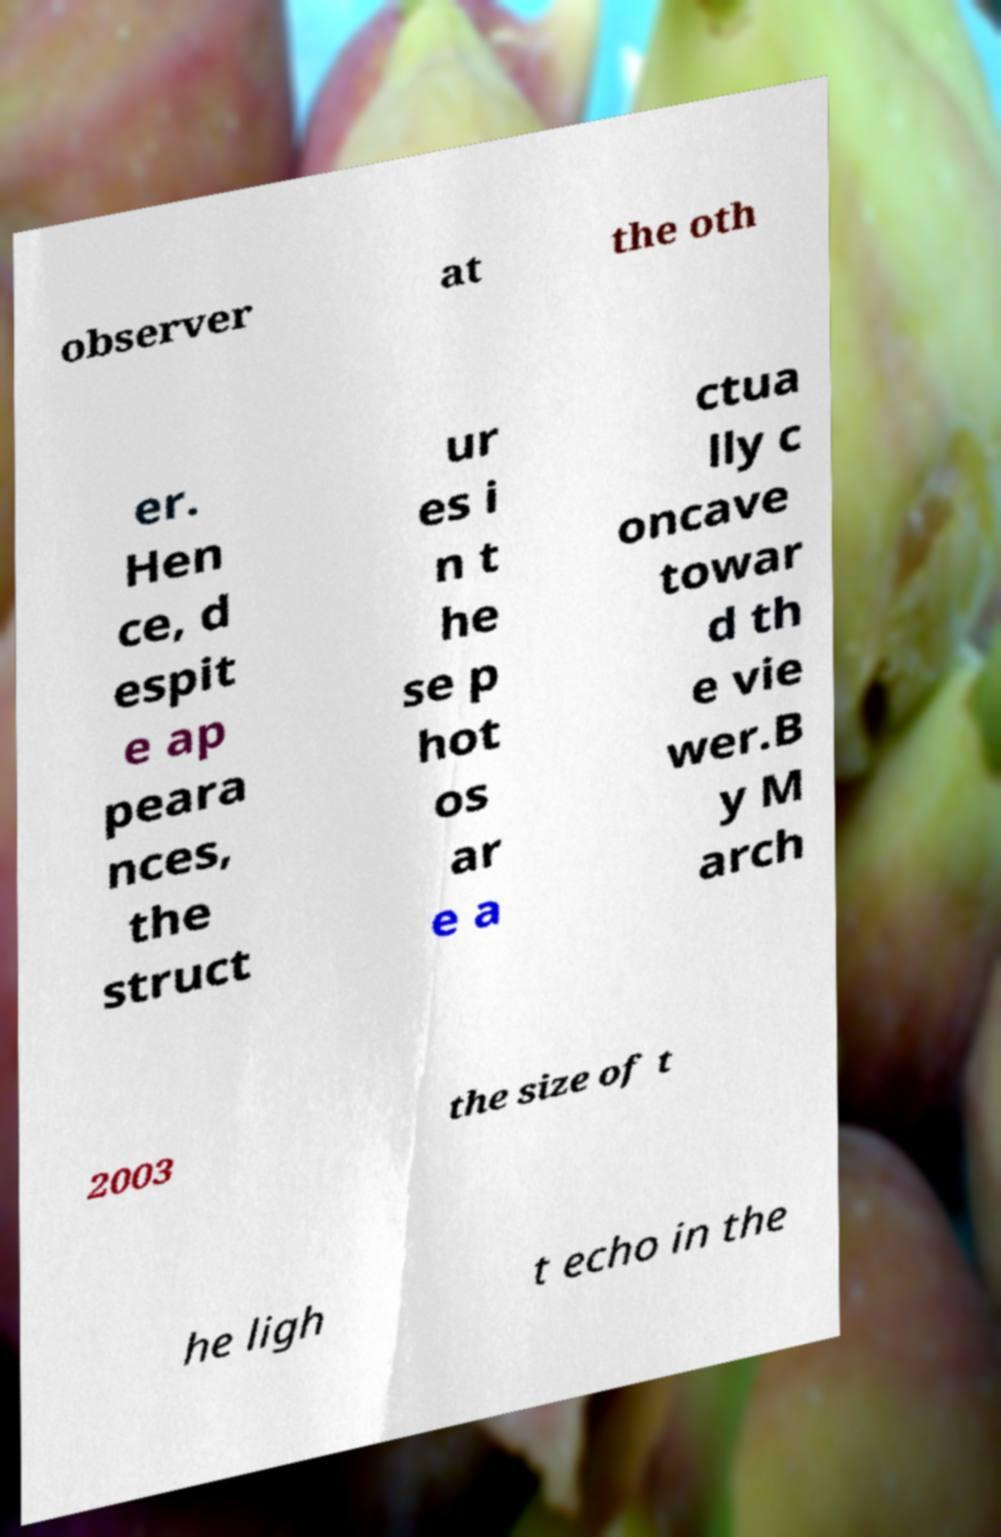Can you accurately transcribe the text from the provided image for me? observer at the oth er. Hen ce, d espit e ap peara nces, the struct ur es i n t he se p hot os ar e a ctua lly c oncave towar d th e vie wer.B y M arch 2003 the size of t he ligh t echo in the 